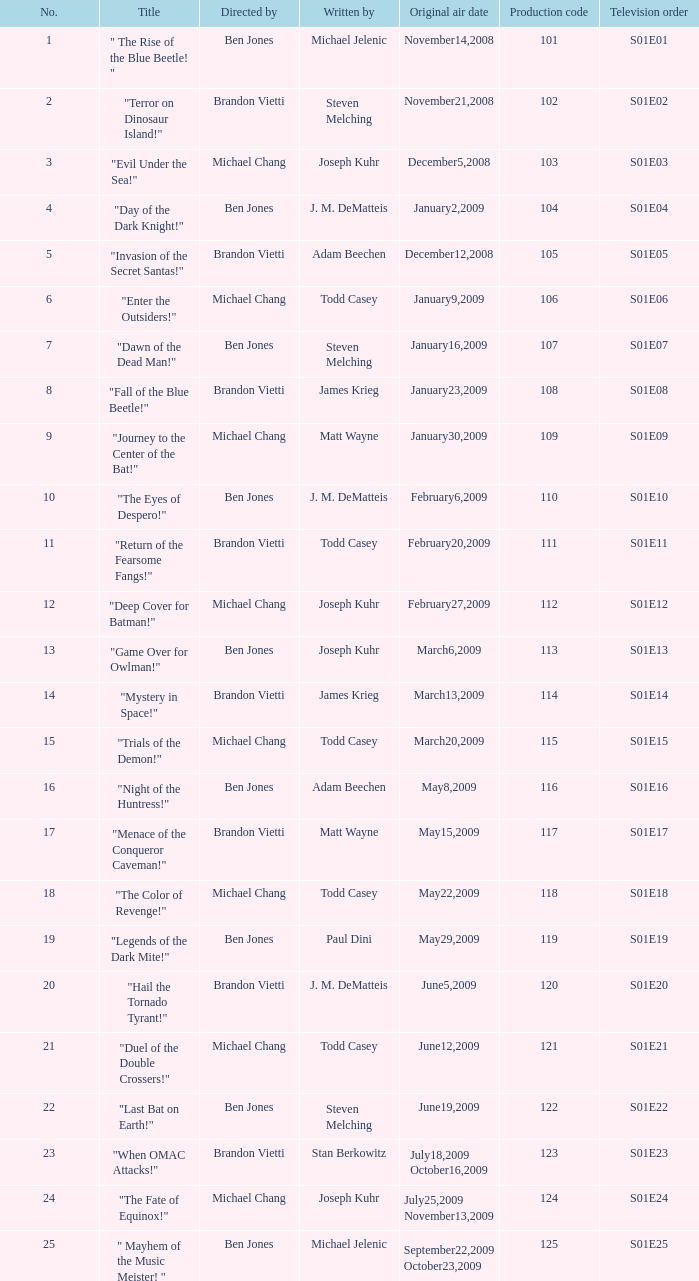Give me the full table as a dictionary. {'header': ['No.', 'Title', 'Directed by', 'Written by', 'Original air date', 'Production code', 'Television order'], 'rows': [['1', '" The Rise of the Blue Beetle! "', 'Ben Jones', 'Michael Jelenic', 'November14,2008', '101', 'S01E01'], ['2', '"Terror on Dinosaur Island!"', 'Brandon Vietti', 'Steven Melching', 'November21,2008', '102', 'S01E02'], ['3', '"Evil Under the Sea!"', 'Michael Chang', 'Joseph Kuhr', 'December5,2008', '103', 'S01E03'], ['4', '"Day of the Dark Knight!"', 'Ben Jones', 'J. M. DeMatteis', 'January2,2009', '104', 'S01E04'], ['5', '"Invasion of the Secret Santas!"', 'Brandon Vietti', 'Adam Beechen', 'December12,2008', '105', 'S01E05'], ['6', '"Enter the Outsiders!"', 'Michael Chang', 'Todd Casey', 'January9,2009', '106', 'S01E06'], ['7', '"Dawn of the Dead Man!"', 'Ben Jones', 'Steven Melching', 'January16,2009', '107', 'S01E07'], ['8', '"Fall of the Blue Beetle!"', 'Brandon Vietti', 'James Krieg', 'January23,2009', '108', 'S01E08'], ['9', '"Journey to the Center of the Bat!"', 'Michael Chang', 'Matt Wayne', 'January30,2009', '109', 'S01E09'], ['10', '"The Eyes of Despero!"', 'Ben Jones', 'J. M. DeMatteis', 'February6,2009', '110', 'S01E10'], ['11', '"Return of the Fearsome Fangs!"', 'Brandon Vietti', 'Todd Casey', 'February20,2009', '111', 'S01E11'], ['12', '"Deep Cover for Batman!"', 'Michael Chang', 'Joseph Kuhr', 'February27,2009', '112', 'S01E12'], ['13', '"Game Over for Owlman!"', 'Ben Jones', 'Joseph Kuhr', 'March6,2009', '113', 'S01E13'], ['14', '"Mystery in Space!"', 'Brandon Vietti', 'James Krieg', 'March13,2009', '114', 'S01E14'], ['15', '"Trials of the Demon!"', 'Michael Chang', 'Todd Casey', 'March20,2009', '115', 'S01E15'], ['16', '"Night of the Huntress!"', 'Ben Jones', 'Adam Beechen', 'May8,2009', '116', 'S01E16'], ['17', '"Menace of the Conqueror Caveman!"', 'Brandon Vietti', 'Matt Wayne', 'May15,2009', '117', 'S01E17'], ['18', '"The Color of Revenge!"', 'Michael Chang', 'Todd Casey', 'May22,2009', '118', 'S01E18'], ['19', '"Legends of the Dark Mite!"', 'Ben Jones', 'Paul Dini', 'May29,2009', '119', 'S01E19'], ['20', '"Hail the Tornado Tyrant!"', 'Brandon Vietti', 'J. M. DeMatteis', 'June5,2009', '120', 'S01E20'], ['21', '"Duel of the Double Crossers!"', 'Michael Chang', 'Todd Casey', 'June12,2009', '121', 'S01E21'], ['22', '"Last Bat on Earth!"', 'Ben Jones', 'Steven Melching', 'June19,2009', '122', 'S01E22'], ['23', '"When OMAC Attacks!"', 'Brandon Vietti', 'Stan Berkowitz', 'July18,2009 October16,2009', '123', 'S01E23'], ['24', '"The Fate of Equinox!"', 'Michael Chang', 'Joseph Kuhr', 'July25,2009 November13,2009', '124', 'S01E24'], ['25', '" Mayhem of the Music Meister! "', 'Ben Jones', 'Michael Jelenic', 'September22,2009 October23,2009', '125', 'S01E25']]} Who penned s01e06? Todd Casey. 